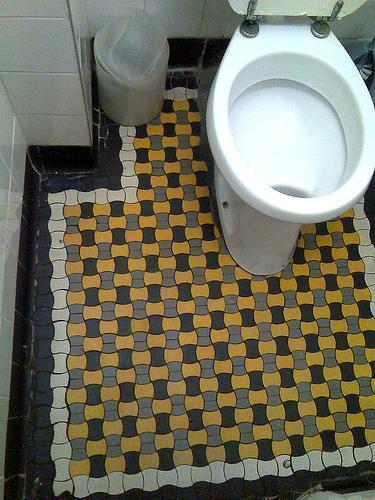How many toilets are there?
Give a very brief answer. 1. 